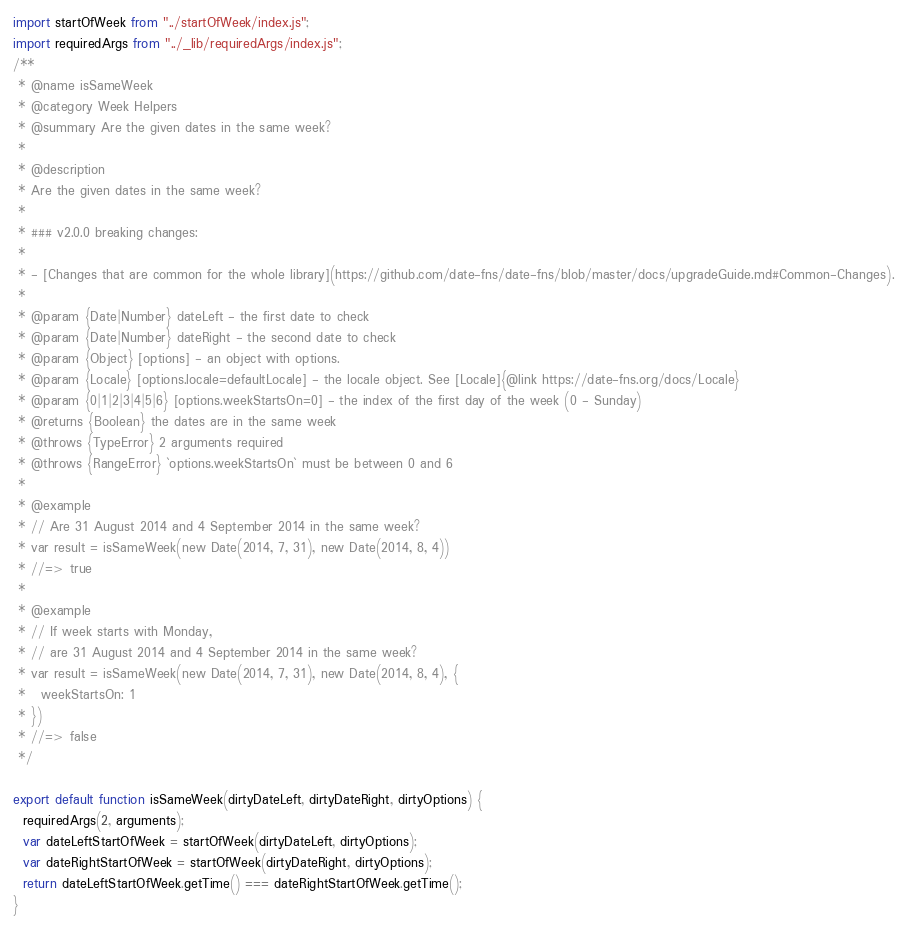<code> <loc_0><loc_0><loc_500><loc_500><_JavaScript_>import startOfWeek from "../startOfWeek/index.js";
import requiredArgs from "../_lib/requiredArgs/index.js";
/**
 * @name isSameWeek
 * @category Week Helpers
 * @summary Are the given dates in the same week?
 *
 * @description
 * Are the given dates in the same week?
 *
 * ### v2.0.0 breaking changes:
 *
 * - [Changes that are common for the whole library](https://github.com/date-fns/date-fns/blob/master/docs/upgradeGuide.md#Common-Changes).
 *
 * @param {Date|Number} dateLeft - the first date to check
 * @param {Date|Number} dateRight - the second date to check
 * @param {Object} [options] - an object with options.
 * @param {Locale} [options.locale=defaultLocale] - the locale object. See [Locale]{@link https://date-fns.org/docs/Locale}
 * @param {0|1|2|3|4|5|6} [options.weekStartsOn=0] - the index of the first day of the week (0 - Sunday)
 * @returns {Boolean} the dates are in the same week
 * @throws {TypeError} 2 arguments required
 * @throws {RangeError} `options.weekStartsOn` must be between 0 and 6
 *
 * @example
 * // Are 31 August 2014 and 4 September 2014 in the same week?
 * var result = isSameWeek(new Date(2014, 7, 31), new Date(2014, 8, 4))
 * //=> true
 *
 * @example
 * // If week starts with Monday,
 * // are 31 August 2014 and 4 September 2014 in the same week?
 * var result = isSameWeek(new Date(2014, 7, 31), new Date(2014, 8, 4), {
 *   weekStartsOn: 1
 * })
 * //=> false
 */

export default function isSameWeek(dirtyDateLeft, dirtyDateRight, dirtyOptions) {
  requiredArgs(2, arguments);
  var dateLeftStartOfWeek = startOfWeek(dirtyDateLeft, dirtyOptions);
  var dateRightStartOfWeek = startOfWeek(dirtyDateRight, dirtyOptions);
  return dateLeftStartOfWeek.getTime() === dateRightStartOfWeek.getTime();
}</code> 